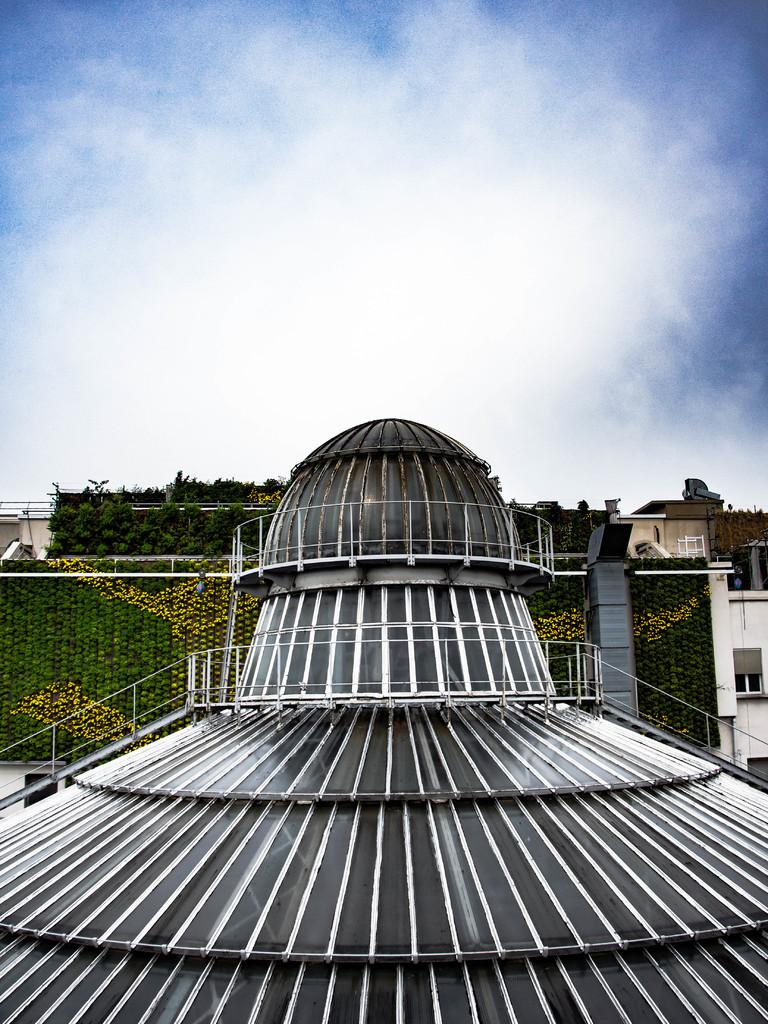What is the main subject of the image? The main subject of the image is the roof of an architecture. What else can be seen in the image besides the roof? There are buildings and plants visible in the image. What is visible in the background of the image? The sky is visible in the background of the image. What can be observed in the sky? Clouds are present in the sky. What grade of steel is used in the construction of the buildings in the image? There is no information about the grade of steel used in the construction of the buildings in the image. 